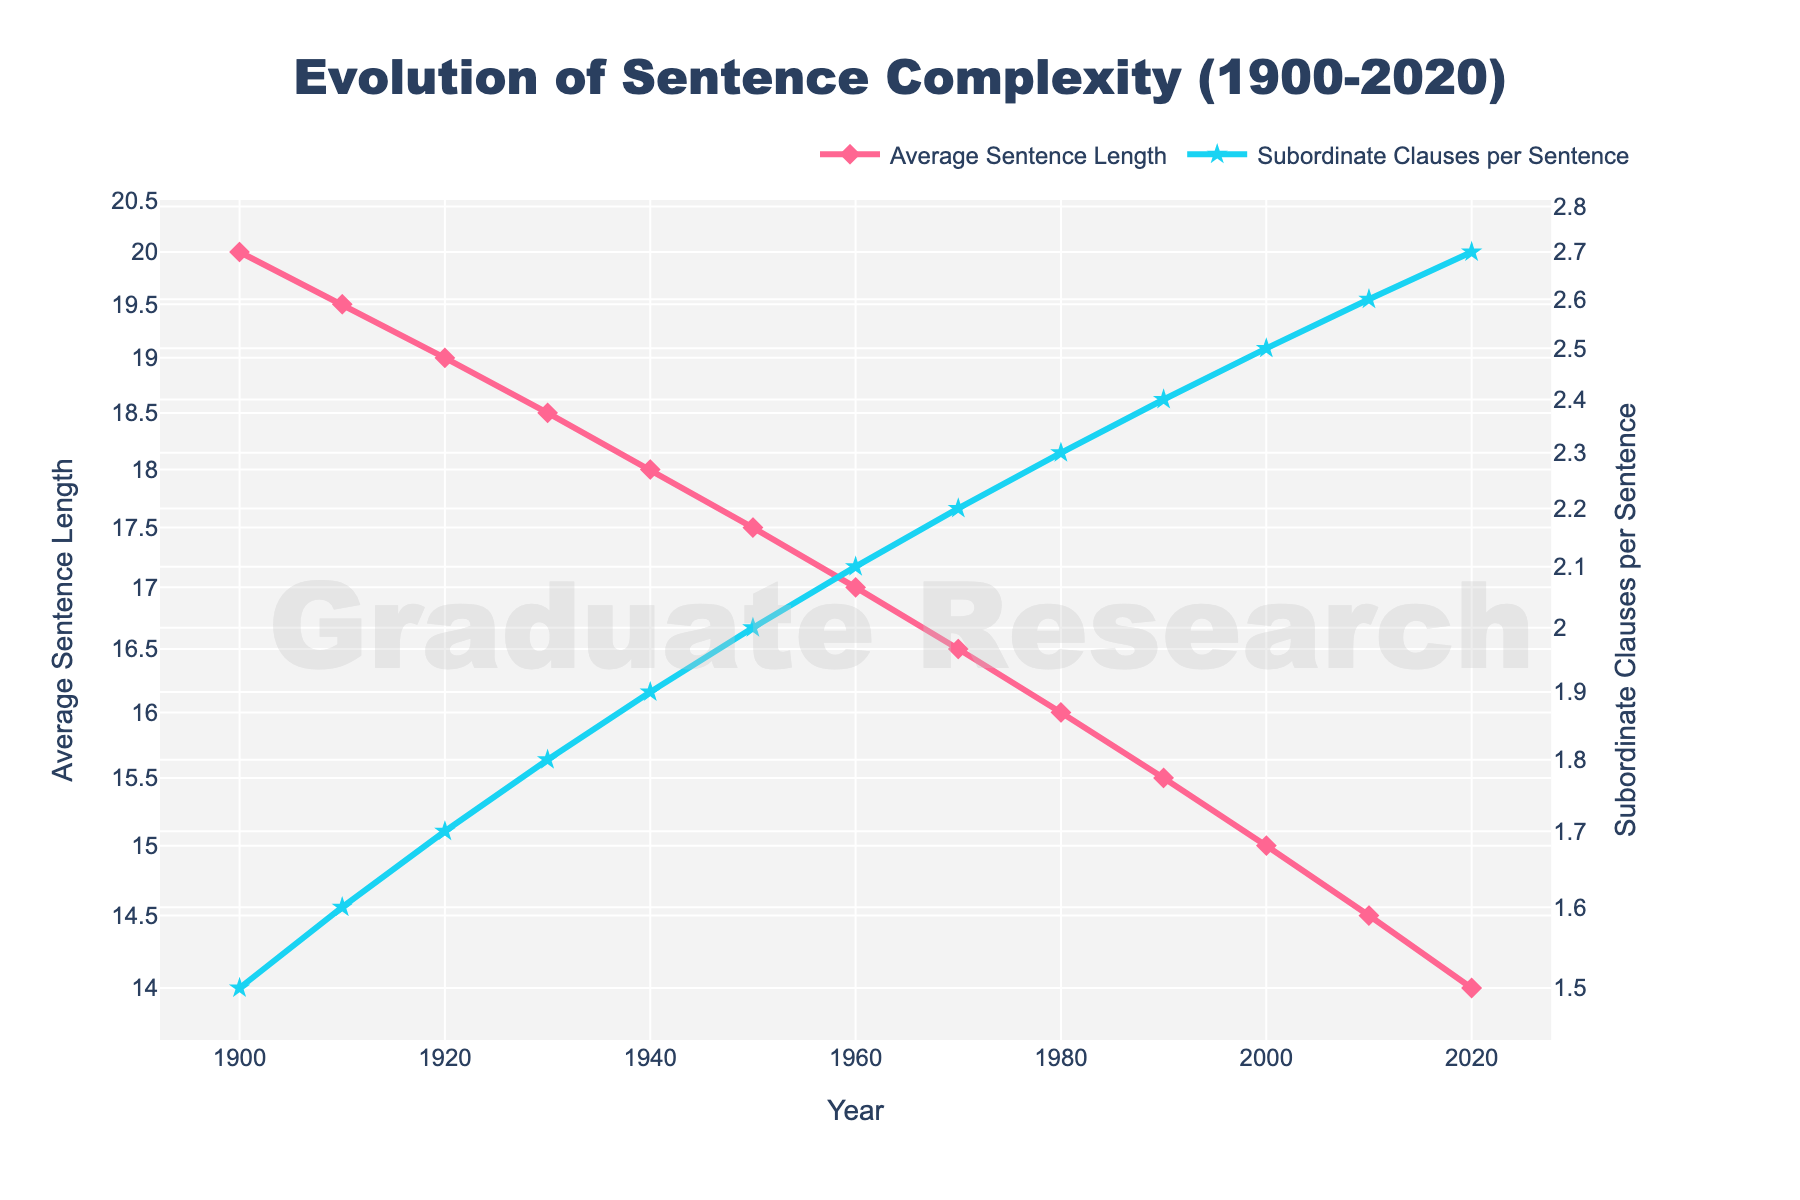What is the title of the figure? The title is displayed at the top center of the figure, reading "Evolution of Sentence Complexity (1900-2020)".
Answer: Evolution of Sentence Complexity (1900-2020) What are the colors used for the "Average Sentence Length" and "Subordinate Clauses per Sentence" lines? The color of the "Average Sentence Length" line is pink, while the "Subordinate Clauses per Sentence" line is light blue, consistently shown in both the legend and the plot lines.
Answer: Pink and light blue How many data points are plotted for both "Average Sentence Length" and "Subordinate Clauses per Sentence"? There is a data point for each decade from 1900 to 2020, totaling 13 points for both lines as visible along the x-axis marked by the "Year".
Answer: 13 Between which years did the "Average Sentence Length" decrease by the largest amount? From 1900 to 2020, we need to find the biggest difference between two consecutive points. The largest decrease happens between 2010 (14.5) and 2020 (14), a decrease of 0.5 units.
Answer: 2010 and 2020 What is the value of "Subordinate Clauses per Sentence" in the year 1940? By locating the year 1940 on the x-axis and following vertically up to the light blue line, the value at 1940 is 1.9.
Answer: 1.9 What is the average "Average Sentence Length" over the years 1900 to 2020? Sum the "Average Sentence Length" values and divide by the number of years (13). (20 + 19.5 + 19 + 18.5 + 18 + 17.5 + 17 + 16.5 + 16 + 15.5 + 15 + 14.5 + 14) / 13 = 18
Answer: 18 Which year had equal number of "Average Sentence Length" and "Subordinate Clauses per Sentence"? By comparing the values each year, it is visibly noticeable that no year has equal values for both "Average Sentence Length" and "Subordinate Clauses per Sentence".
Answer: None How does the log scale affect the appearance of the "Average Sentence Length" trend over time? On a log scale, even small changes in low values become more noticeable, meanwhile larger values will appear to change less sharply. This makes the general downward trend in "Average Sentence Length" appear more linear rather than exponentially decreasing.
Answer: Linearized trend What is the difference in "Subordinate Clauses per Sentence" between 1900 and 2020? Subtract the value in 1900 (1.5) from the value in 2020 (2.7), the difference is 2.7 - 1.5 = 1.2.
Answer: 1.2 If the trends continued as shown, in which future decade would we expect to reach 2.8 subordinate clauses per sentence? The "Subordinate Clauses per Sentence" line increases linearly over time. Seeing the increments of 0.1 per decade, we would expect 2.8 in the next decade after 2020, which is 2030.
Answer: 2030 